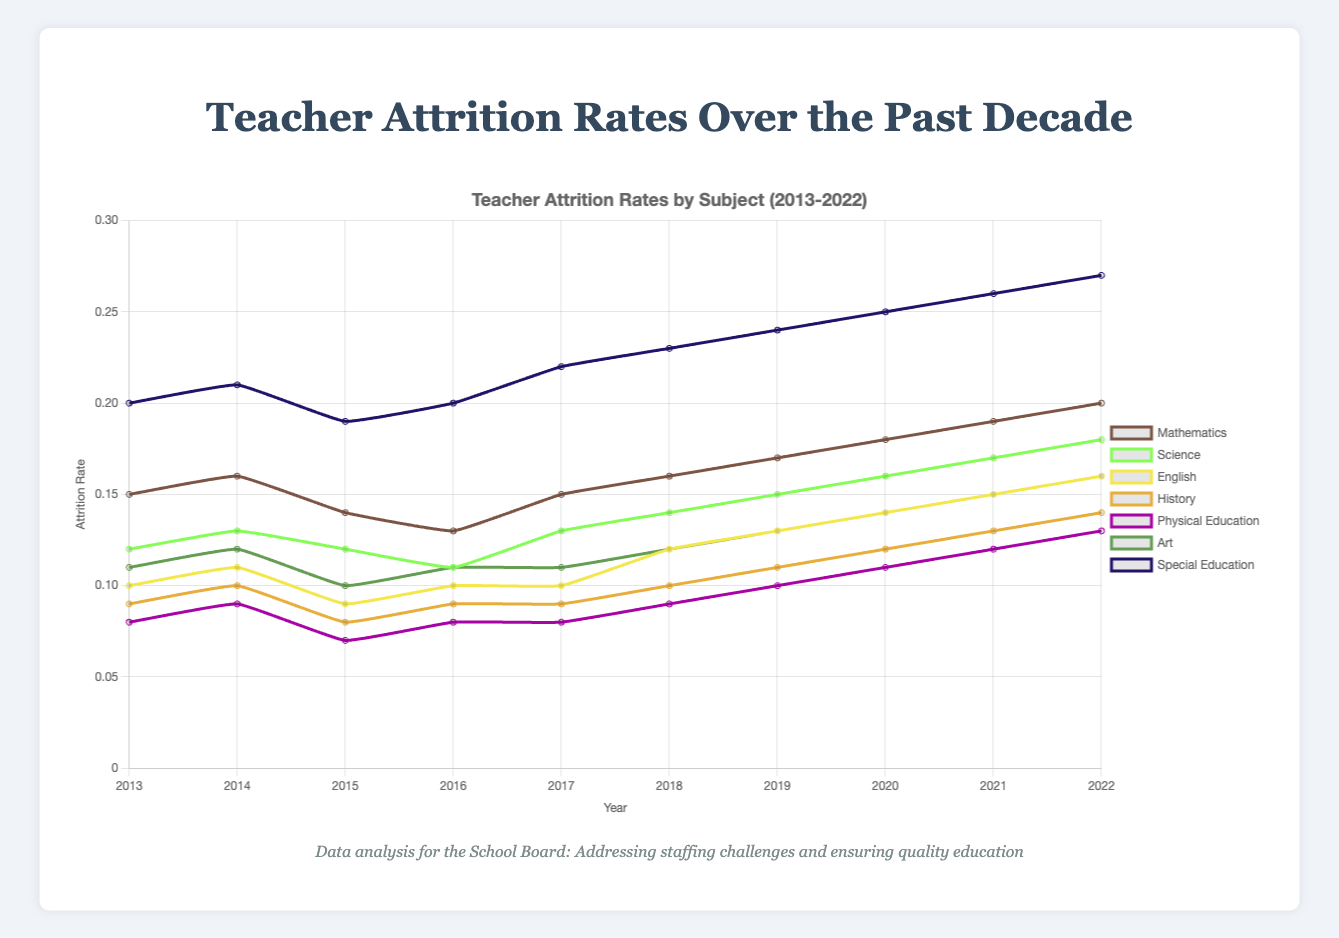What subject had the highest teacher attrition rate in 2013? Look for the subject with the highest value in the attrition rates for 2013. Special Education had the highest rate at 0.20.
Answer: Special Education What trend can be observed in the attrition rates for Mathematics teachers from 2013 to 2022? Observe the values and the line representing Mathematics from 2013 to 2022. The trend is that the attrition rate has increased over time from 0.15 in 2013 to 0.20 in 2022.
Answer: Increased Which year had the lowest attrition rate for Physical Education teachers? Look for the year with the lowest attrition rate in the Physical Education data series. 2015 had the lowest rate at 0.07.
Answer: 2015 Between Science and History, which subject had a higher attrition rate in 2020? Compare the attrition rates for Science and History in 2020. Science had 0.16, while History had 0.12. Therefore, Science had a higher attrition rate.
Answer: Science What is the average attrition rate for English teachers from 2018 to 2022? Sum the attrition rates for English from 2018 (0.12), 2019 (0.13), 2020 (0.14), 2021 (0.15), and 2022 (0.16), then divide by 5. (0.12 + 0.13 + 0.14 + 0.15 + 0.16) / 5 = 0.14
Answer: 0.14 How did the attrition rate for Special Education change from 2014 to 2022? Identify the rates for Special Education in 2014 (0.21) and 2022 (0.27) and calculate the difference. There was an increase of 0.06 (0.27 - 0.21).
Answer: Increased by 0.06 What visual aspect of the chart indicates which subjects have the highest attrition rates? The height of the lines on the y-axis shows attrition rates, with higher lines indicating higher rates. Special Education and Mathematics have the highest values and thus highest lines.
Answer: Height of the lines Which three subjects had the highest attrition rates in 2022? Look at the attrition rates for all subjects in 2022 and identify the top three: Special Education (0.27), Mathematics (0.20), and Science (0.18).
Answer: Special Education, Mathematics, Science If you combine the attrition rates for History and Art in 2016, what value do you get? Add the attrition rates for History (0.09) and Art (0.11). 0.09 + 0.11 = 0.20
Answer: 0.20 Did any subjects have a decreasing trend in attrition rates from 2016 to 2017? Compare the attrition rates for all subjects between 2016 and 2017. Mathematics decreased from 0.13 to 0.15, Science increased from 0.11 to 0.13, English remained the same.
Answer: No subjects had a decreasing trend 